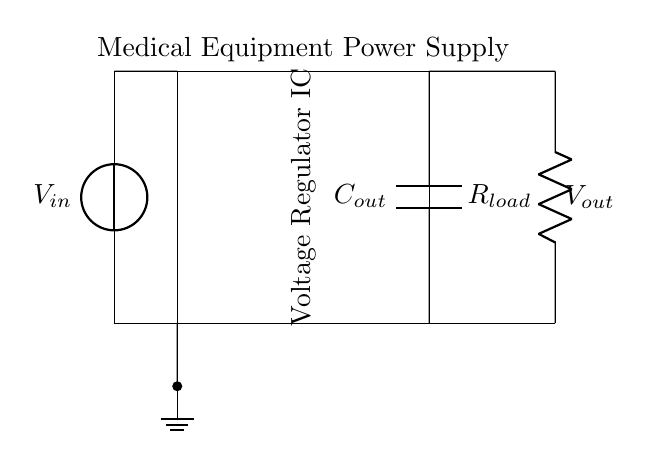What is the input voltage type in this circuit? The input voltage is represented by the voltage source component labeled V_in. This indicates that the circuit receives a direct current (DC) voltage to operate.
Answer: DC What component converts the input voltage in this circuit? The component that converts the input voltage is labeled as the Voltage Regulator IC. Its purpose is to regulate the input voltage to a stable output voltage suitable for medical equipment.
Answer: Voltage Regulator IC What is the output of the voltage regulator? The output of the voltage regulator is connected to a load resistor labeled R_load, indicating that it delivers a specific regulated voltage to that load. The value of this output voltage is not directly labeled on the diagram but is crucial for operation.
Answer: V_out How many capacitors are present in this circuit? The circuit diagram shows one capacitor labeled C_out connected at the output, which is essential for stabilizing the output voltage.
Answer: One What is the role of the output capacitor in this circuit? The output capacitor C_out smoothens the output voltage by filtering out any fluctuations, ensuring stable performance for the connected medical equipment. Its function is vital to maintain voltage regulation under varying load conditions.
Answer: Stabilization What type of load resistor is used in this circuit? The load resistor labeled R_load can be assumed to be a resistive load typical in medical equipment, which is essential for allowing current to flow when connected to the output voltage from the regulator.
Answer: Resistive What does the ground symbol indicate in this circuit? The ground symbol shows a reference point for the circuit and serves as a common return path for current. It connects to the negative side of the input voltage source, establishing a zero-voltage reference for the entire circuit.
Answer: Reference point 